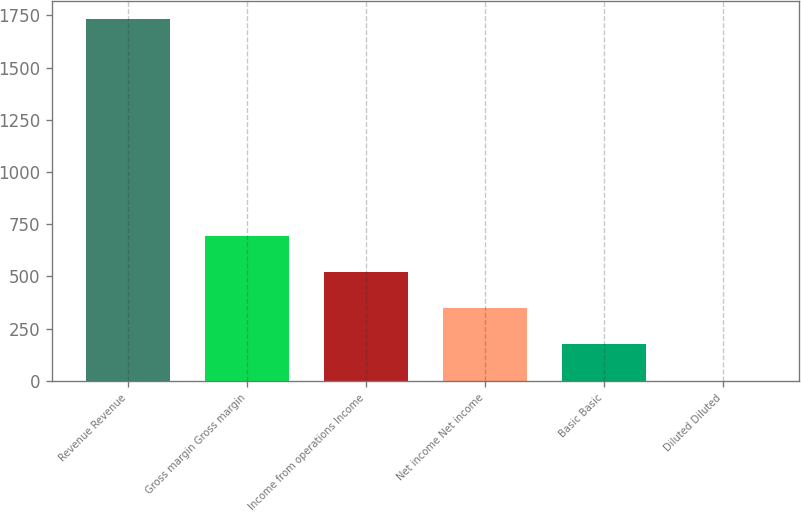Convert chart. <chart><loc_0><loc_0><loc_500><loc_500><bar_chart><fcel>Revenue Revenue<fcel>Gross margin Gross margin<fcel>Income from operations Income<fcel>Net income Net income<fcel>Basic Basic<fcel>Diluted Diluted<nl><fcel>1734<fcel>693.87<fcel>520.51<fcel>347.15<fcel>173.79<fcel>0.43<nl></chart> 